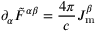Convert formula to latex. <formula><loc_0><loc_0><loc_500><loc_500>\partial _ { \alpha } { { \tilde { F } } ^ { \alpha \beta } } = { \frac { 4 \pi } { c } } J _ { m } ^ { \beta }</formula> 